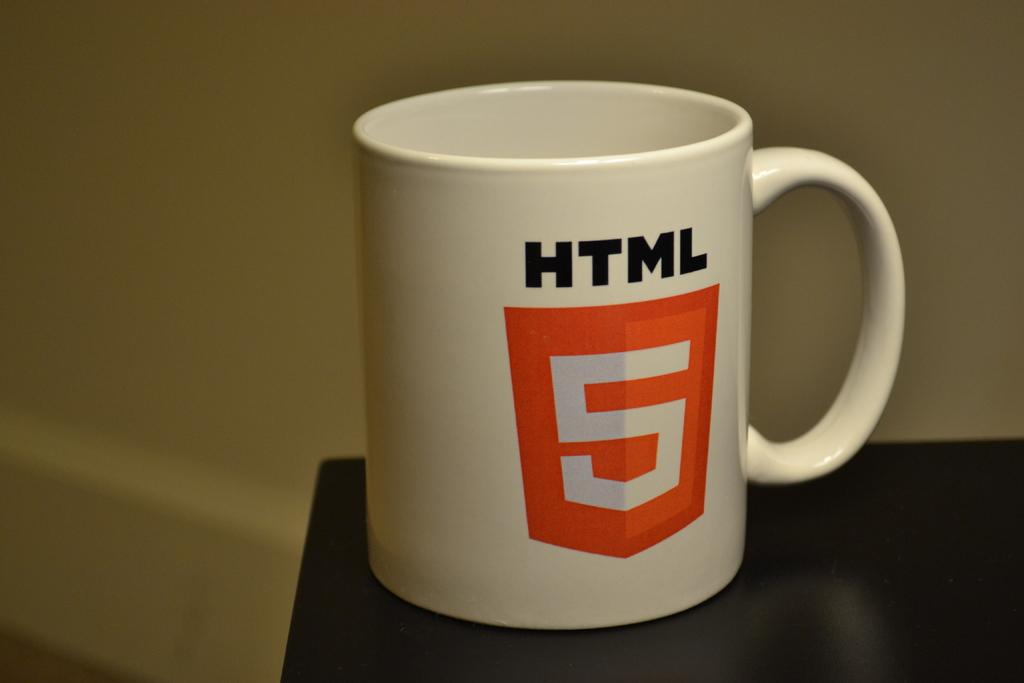<image>
Describe the image concisely. A white coffee mug that sits on a table reads, HTML and the number five appears  below it in an orange colored area. 